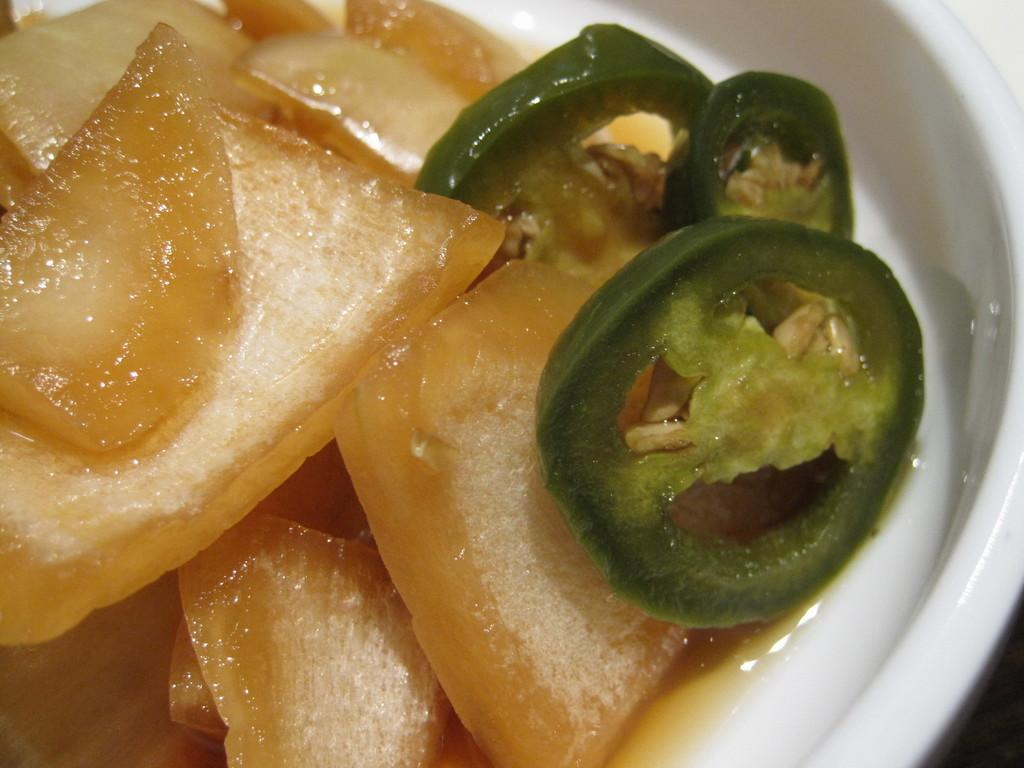What color is the bowl in the image? The bowl in the image is white colored. What is inside the bowl? The bowl contains a food item. Can you describe the appearance of the food item? The food item has cream, orange, and green colors. How many books are stacked next to the bowl in the image? There are no books present in the image. What type of sponge is being used to clean the bowl in the image? There is no sponge visible in the image, and the bowl is not being cleaned. 